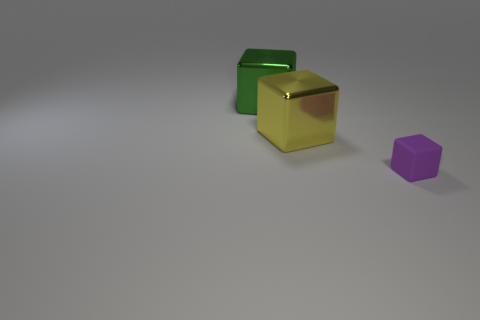Add 2 small objects. How many objects exist? 5 Subtract all small things. Subtract all large green blocks. How many objects are left? 1 Add 1 metal blocks. How many metal blocks are left? 3 Add 1 large shiny cubes. How many large shiny cubes exist? 3 Subtract 0 blue cylinders. How many objects are left? 3 